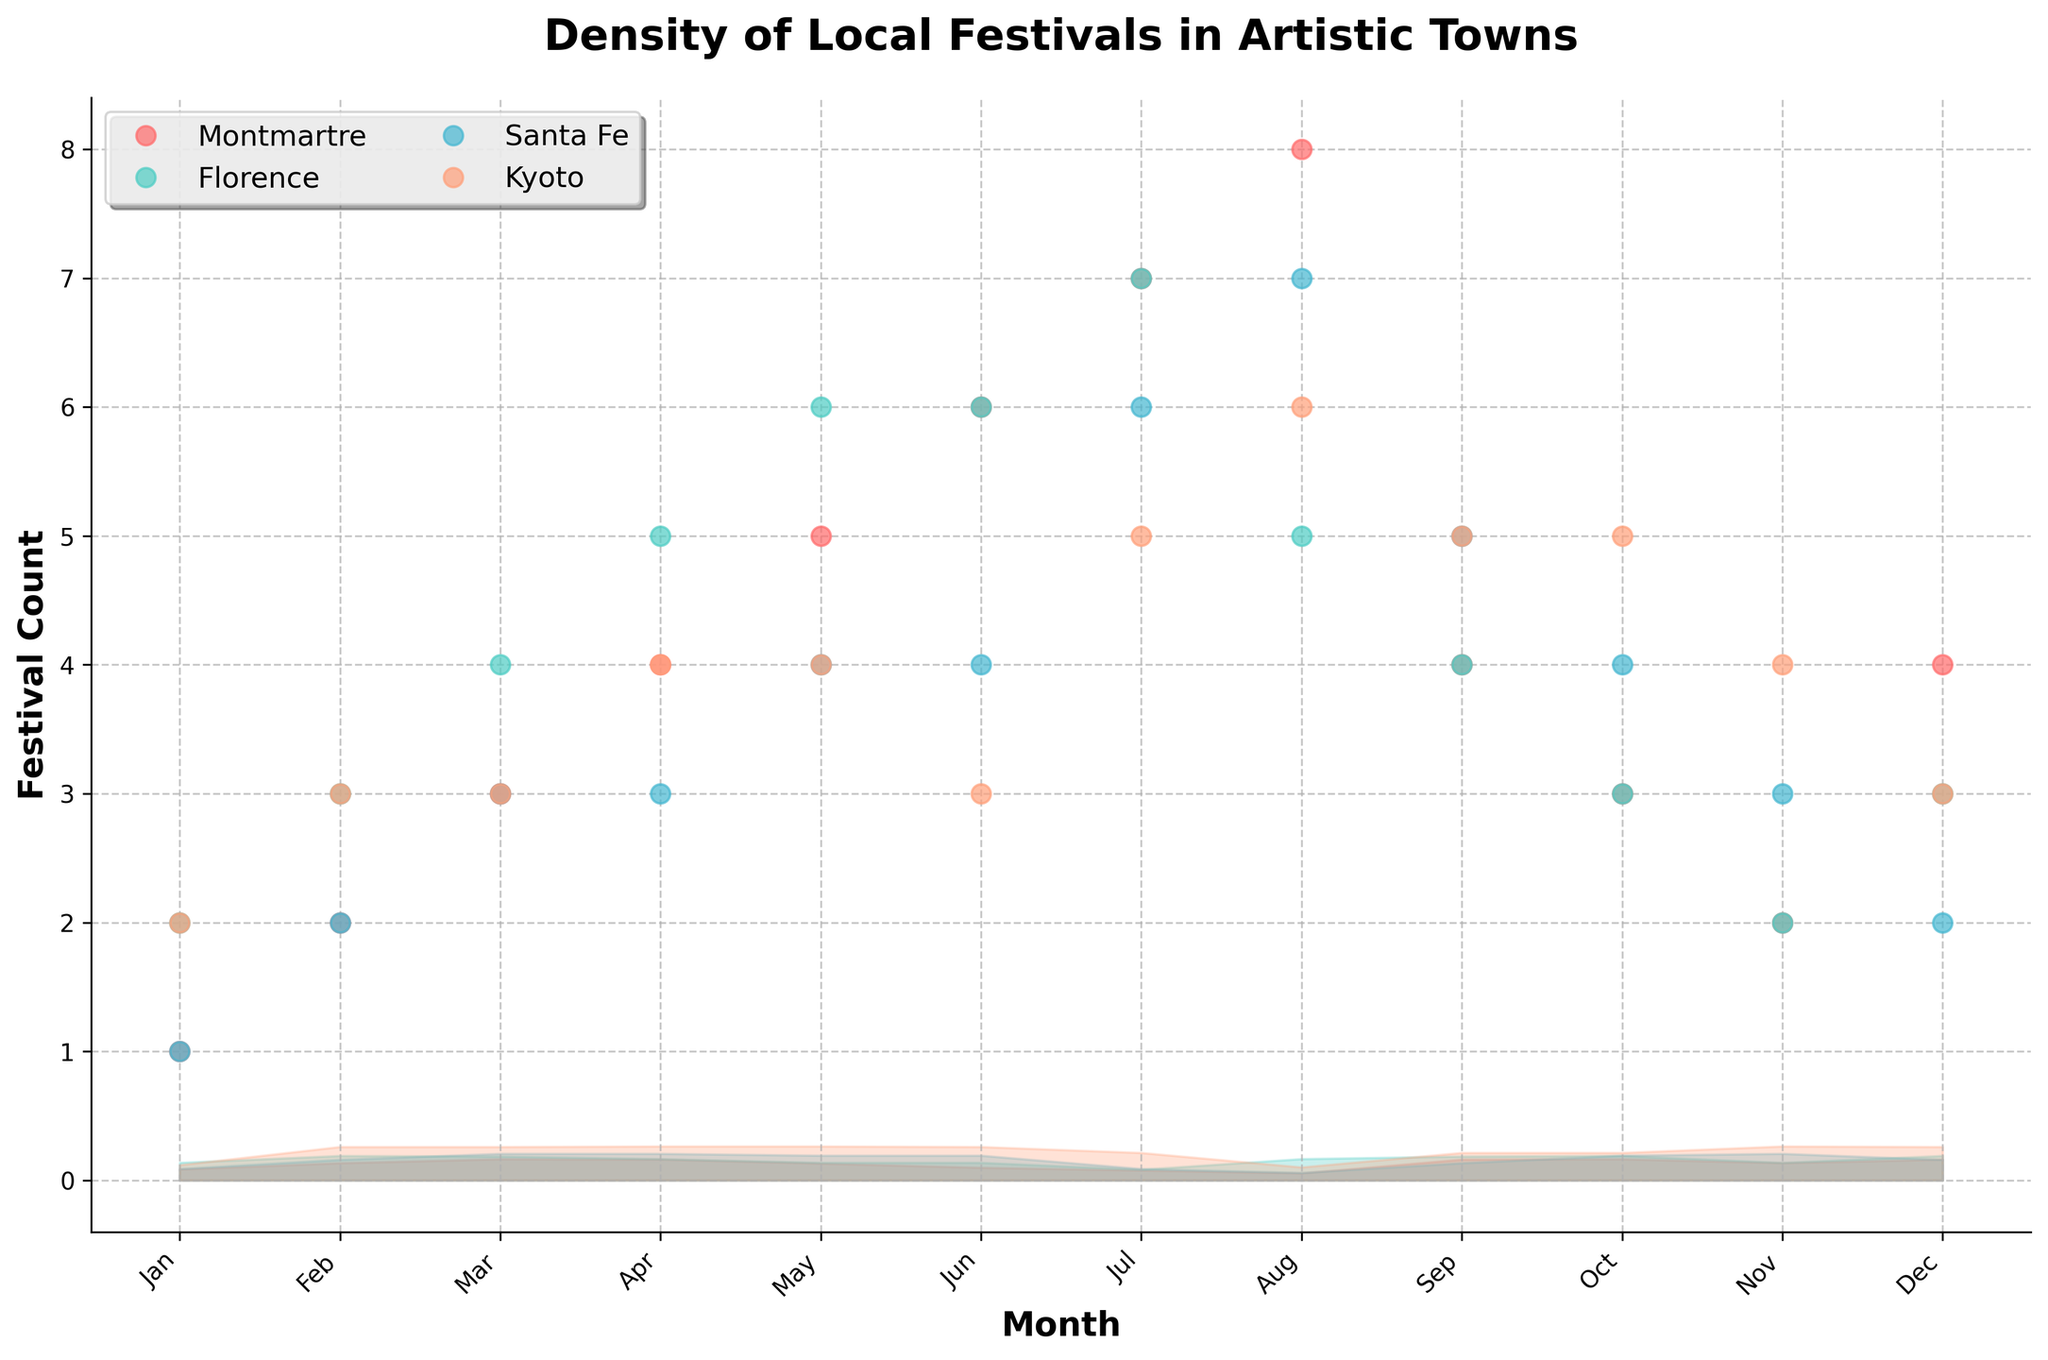What's the title of the figure? The title of the figure is displayed at the top of the plot in a bold font. It provides an overview of what the plot is about.
Answer: Density of Local Festivals in Artistic Towns Which month has the highest festival count in Montmartre? By looking at the plot, Montmartre has the highest festival count in August. This can be seen where the marker's peak is highest on the 'Montmartre' line for that month.
Answer: August Are there any months where Florence and Santa Fe have the same festival count? Compare the festival counts month by month between Florence and Santa Fe. Both Florence and Santa Fe have the same festival count (6) in July.
Answer: July In which town is the festival count most variable throughout the year? Assess the spread and range of festival counts over the year. Montmartre shows the most variability, peaking in August and dropping to its lowest in January.
Answer: Montmartre How does the festival count in January compare across the towns? Look at the markers for January in all four towns. Montmartre has 1, Florence 2, Santa Fe 1, and Kyoto 2. Therefore, Montmartre and Santa Fe have equal counts, and Kyoto and Florence have higher but equal counts.
Answer: Florence and Kyoto have the highest counts (2), Montmartre and Santa Fe have the lowest (1) Which town has the fewest festivals in February? Check the festival counts in February for each town. Montmartre and Santa Fe both have the fewest with 2 festivals, while Florence and Kyoto have 3 each.
Answer: Montmartre and Santa Fe What is the range of festival counts for Santa Fe? Identify the highest and lowest festival counts for Santa Fe over the months. The lowest is 1 and the highest is 7. So, the range is 7 - 1 = 6.
Answer: 6 During which month does Kyoto reach its peak festival count? Look at the markers for Kyoto and identify the month when it reaches its peak. Kyoto reaches its peak in July and October, with a count of 5 festivals.
Answer: July and October What’s the mean festival count for Florence in the first six months? Compute the average of Florence's festival counts from January to June. Add up the counts (2+3+4+5+6+6 = 26) and divide by 6.
Answer: 4.33 Which town has the least variation in festival counts? Assess the overall spread of festival counts year-round. Florence's festival counts show the least variation, consistently ranging between 2 and 7.
Answer: Florence 